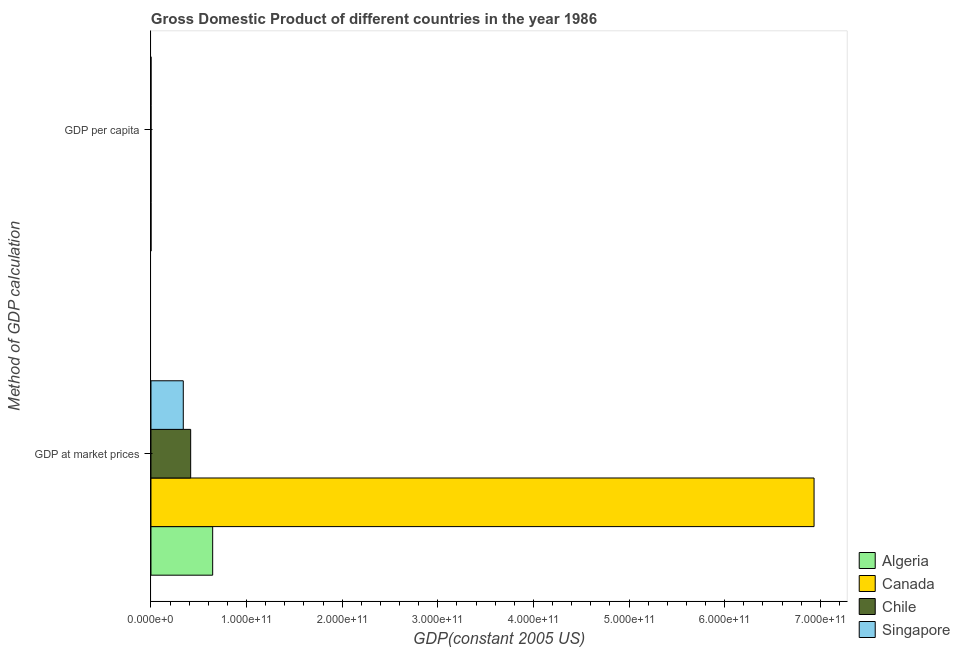How many different coloured bars are there?
Make the answer very short. 4. Are the number of bars per tick equal to the number of legend labels?
Provide a succinct answer. Yes. Are the number of bars on each tick of the Y-axis equal?
Your response must be concise. Yes. How many bars are there on the 1st tick from the bottom?
Your answer should be compact. 4. What is the label of the 1st group of bars from the top?
Offer a very short reply. GDP per capita. What is the gdp per capita in Algeria?
Offer a terse response. 2776.84. Across all countries, what is the maximum gdp per capita?
Keep it short and to the point. 2.65e+04. Across all countries, what is the minimum gdp at market prices?
Offer a terse response. 3.38e+1. In which country was the gdp at market prices maximum?
Give a very brief answer. Canada. In which country was the gdp per capita minimum?
Offer a terse response. Algeria. What is the total gdp at market prices in the graph?
Make the answer very short. 8.33e+11. What is the difference between the gdp at market prices in Singapore and that in Chile?
Your answer should be compact. -7.72e+09. What is the difference between the gdp at market prices in Algeria and the gdp per capita in Singapore?
Provide a succinct answer. 6.45e+1. What is the average gdp at market prices per country?
Keep it short and to the point. 2.08e+11. What is the difference between the gdp per capita and gdp at market prices in Singapore?
Your answer should be compact. -3.38e+1. In how many countries, is the gdp per capita greater than 300000000000 US$?
Your response must be concise. 0. What is the ratio of the gdp per capita in Chile to that in Algeria?
Give a very brief answer. 1.22. In how many countries, is the gdp at market prices greater than the average gdp at market prices taken over all countries?
Offer a very short reply. 1. What does the 2nd bar from the bottom in GDP at market prices represents?
Ensure brevity in your answer.  Canada. Are all the bars in the graph horizontal?
Give a very brief answer. Yes. What is the difference between two consecutive major ticks on the X-axis?
Your response must be concise. 1.00e+11. Where does the legend appear in the graph?
Your answer should be compact. Bottom right. How many legend labels are there?
Provide a succinct answer. 4. What is the title of the graph?
Your answer should be very brief. Gross Domestic Product of different countries in the year 1986. What is the label or title of the X-axis?
Make the answer very short. GDP(constant 2005 US). What is the label or title of the Y-axis?
Provide a short and direct response. Method of GDP calculation. What is the GDP(constant 2005 US) of Algeria in GDP at market prices?
Your answer should be very brief. 6.45e+1. What is the GDP(constant 2005 US) of Canada in GDP at market prices?
Your response must be concise. 6.93e+11. What is the GDP(constant 2005 US) of Chile in GDP at market prices?
Offer a terse response. 4.15e+1. What is the GDP(constant 2005 US) of Singapore in GDP at market prices?
Your response must be concise. 3.38e+1. What is the GDP(constant 2005 US) in Algeria in GDP per capita?
Make the answer very short. 2776.84. What is the GDP(constant 2005 US) of Canada in GDP per capita?
Your answer should be very brief. 2.65e+04. What is the GDP(constant 2005 US) of Chile in GDP per capita?
Give a very brief answer. 3374.97. What is the GDP(constant 2005 US) in Singapore in GDP per capita?
Give a very brief answer. 1.24e+04. Across all Method of GDP calculation, what is the maximum GDP(constant 2005 US) in Algeria?
Provide a succinct answer. 6.45e+1. Across all Method of GDP calculation, what is the maximum GDP(constant 2005 US) in Canada?
Your answer should be compact. 6.93e+11. Across all Method of GDP calculation, what is the maximum GDP(constant 2005 US) in Chile?
Provide a succinct answer. 4.15e+1. Across all Method of GDP calculation, what is the maximum GDP(constant 2005 US) of Singapore?
Make the answer very short. 3.38e+1. Across all Method of GDP calculation, what is the minimum GDP(constant 2005 US) in Algeria?
Your response must be concise. 2776.84. Across all Method of GDP calculation, what is the minimum GDP(constant 2005 US) in Canada?
Your answer should be very brief. 2.65e+04. Across all Method of GDP calculation, what is the minimum GDP(constant 2005 US) of Chile?
Provide a short and direct response. 3374.97. Across all Method of GDP calculation, what is the minimum GDP(constant 2005 US) of Singapore?
Give a very brief answer. 1.24e+04. What is the total GDP(constant 2005 US) of Algeria in the graph?
Give a very brief answer. 6.45e+1. What is the total GDP(constant 2005 US) of Canada in the graph?
Your response must be concise. 6.93e+11. What is the total GDP(constant 2005 US) of Chile in the graph?
Offer a very short reply. 4.15e+1. What is the total GDP(constant 2005 US) in Singapore in the graph?
Give a very brief answer. 3.38e+1. What is the difference between the GDP(constant 2005 US) of Algeria in GDP at market prices and that in GDP per capita?
Provide a short and direct response. 6.45e+1. What is the difference between the GDP(constant 2005 US) in Canada in GDP at market prices and that in GDP per capita?
Offer a terse response. 6.93e+11. What is the difference between the GDP(constant 2005 US) in Chile in GDP at market prices and that in GDP per capita?
Your answer should be compact. 4.15e+1. What is the difference between the GDP(constant 2005 US) in Singapore in GDP at market prices and that in GDP per capita?
Provide a short and direct response. 3.38e+1. What is the difference between the GDP(constant 2005 US) of Algeria in GDP at market prices and the GDP(constant 2005 US) of Canada in GDP per capita?
Make the answer very short. 6.45e+1. What is the difference between the GDP(constant 2005 US) of Algeria in GDP at market prices and the GDP(constant 2005 US) of Chile in GDP per capita?
Give a very brief answer. 6.45e+1. What is the difference between the GDP(constant 2005 US) of Algeria in GDP at market prices and the GDP(constant 2005 US) of Singapore in GDP per capita?
Provide a short and direct response. 6.45e+1. What is the difference between the GDP(constant 2005 US) of Canada in GDP at market prices and the GDP(constant 2005 US) of Chile in GDP per capita?
Make the answer very short. 6.93e+11. What is the difference between the GDP(constant 2005 US) in Canada in GDP at market prices and the GDP(constant 2005 US) in Singapore in GDP per capita?
Offer a very short reply. 6.93e+11. What is the difference between the GDP(constant 2005 US) of Chile in GDP at market prices and the GDP(constant 2005 US) of Singapore in GDP per capita?
Give a very brief answer. 4.15e+1. What is the average GDP(constant 2005 US) in Algeria per Method of GDP calculation?
Provide a succinct answer. 3.23e+1. What is the average GDP(constant 2005 US) in Canada per Method of GDP calculation?
Provide a succinct answer. 3.47e+11. What is the average GDP(constant 2005 US) in Chile per Method of GDP calculation?
Ensure brevity in your answer.  2.08e+1. What is the average GDP(constant 2005 US) in Singapore per Method of GDP calculation?
Give a very brief answer. 1.69e+1. What is the difference between the GDP(constant 2005 US) in Algeria and GDP(constant 2005 US) in Canada in GDP at market prices?
Ensure brevity in your answer.  -6.29e+11. What is the difference between the GDP(constant 2005 US) of Algeria and GDP(constant 2005 US) of Chile in GDP at market prices?
Your answer should be very brief. 2.30e+1. What is the difference between the GDP(constant 2005 US) in Algeria and GDP(constant 2005 US) in Singapore in GDP at market prices?
Keep it short and to the point. 3.07e+1. What is the difference between the GDP(constant 2005 US) in Canada and GDP(constant 2005 US) in Chile in GDP at market prices?
Your answer should be compact. 6.52e+11. What is the difference between the GDP(constant 2005 US) of Canada and GDP(constant 2005 US) of Singapore in GDP at market prices?
Provide a succinct answer. 6.60e+11. What is the difference between the GDP(constant 2005 US) of Chile and GDP(constant 2005 US) of Singapore in GDP at market prices?
Offer a terse response. 7.72e+09. What is the difference between the GDP(constant 2005 US) in Algeria and GDP(constant 2005 US) in Canada in GDP per capita?
Ensure brevity in your answer.  -2.37e+04. What is the difference between the GDP(constant 2005 US) in Algeria and GDP(constant 2005 US) in Chile in GDP per capita?
Your response must be concise. -598.13. What is the difference between the GDP(constant 2005 US) of Algeria and GDP(constant 2005 US) of Singapore in GDP per capita?
Make the answer very short. -9589.66. What is the difference between the GDP(constant 2005 US) of Canada and GDP(constant 2005 US) of Chile in GDP per capita?
Your response must be concise. 2.31e+04. What is the difference between the GDP(constant 2005 US) in Canada and GDP(constant 2005 US) in Singapore in GDP per capita?
Your answer should be compact. 1.41e+04. What is the difference between the GDP(constant 2005 US) in Chile and GDP(constant 2005 US) in Singapore in GDP per capita?
Your answer should be very brief. -8991.52. What is the ratio of the GDP(constant 2005 US) in Algeria in GDP at market prices to that in GDP per capita?
Make the answer very short. 2.32e+07. What is the ratio of the GDP(constant 2005 US) in Canada in GDP at market prices to that in GDP per capita?
Offer a terse response. 2.62e+07. What is the ratio of the GDP(constant 2005 US) in Chile in GDP at market prices to that in GDP per capita?
Your answer should be compact. 1.23e+07. What is the ratio of the GDP(constant 2005 US) in Singapore in GDP at market prices to that in GDP per capita?
Your answer should be very brief. 2.73e+06. What is the difference between the highest and the second highest GDP(constant 2005 US) in Algeria?
Your response must be concise. 6.45e+1. What is the difference between the highest and the second highest GDP(constant 2005 US) of Canada?
Make the answer very short. 6.93e+11. What is the difference between the highest and the second highest GDP(constant 2005 US) in Chile?
Your response must be concise. 4.15e+1. What is the difference between the highest and the second highest GDP(constant 2005 US) of Singapore?
Your answer should be compact. 3.38e+1. What is the difference between the highest and the lowest GDP(constant 2005 US) in Algeria?
Offer a terse response. 6.45e+1. What is the difference between the highest and the lowest GDP(constant 2005 US) of Canada?
Give a very brief answer. 6.93e+11. What is the difference between the highest and the lowest GDP(constant 2005 US) in Chile?
Give a very brief answer. 4.15e+1. What is the difference between the highest and the lowest GDP(constant 2005 US) in Singapore?
Offer a terse response. 3.38e+1. 